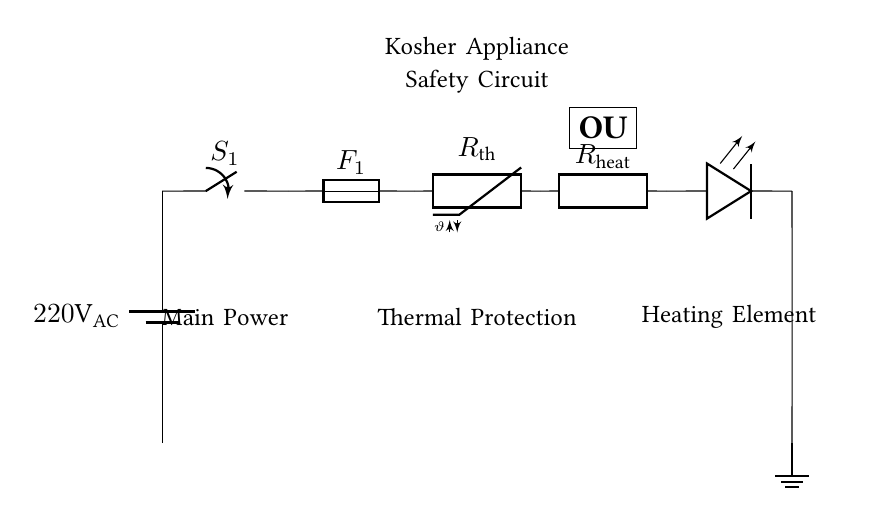What is the main power source voltage? The circuit diagram indicates the main power source is labeled as 220V AC, which is denoted at the battery symbol at the start of the circuit.
Answer: 220V AC What component provides thermal protection? The circuit shows a thermistor labeled as Rth, which is specifically designed for thermal protection in the circuit.
Answer: Rth What does the OU symbol represent? The diagram includes a rectangular shape labeled OU, which signifies that the appliance has kosher certification, indicating it meets specific dietary laws.
Answer: Kosher certification Which component indicates if the heating element is on? The LED symbol positioned after the heating element serves as an indicator that shows whether the heating element is operational, as the LED lights up when power passes through.
Answer: LED indicator What happens if the current exceeds safe levels? The circuit features a fuse labeled F1, which is designed to break the circuit and interrupt current flow if it exceeds safe levels, preventing potential hazards.
Answer: Fuse Explain the sequence of activation for the appliance. The activation begins with closing the main switch S1, allowing current to flow through the fuse F1 and the thermistor Rth. If Rth senses a safe temperature, current continues to the heating element Rheat, eventually activating the LED indicator to show it's on. In case of overheating, Rth will prevent current flow, protecting the appliance.
Answer: Switch, Fuse, Thermistor, Heating Element 